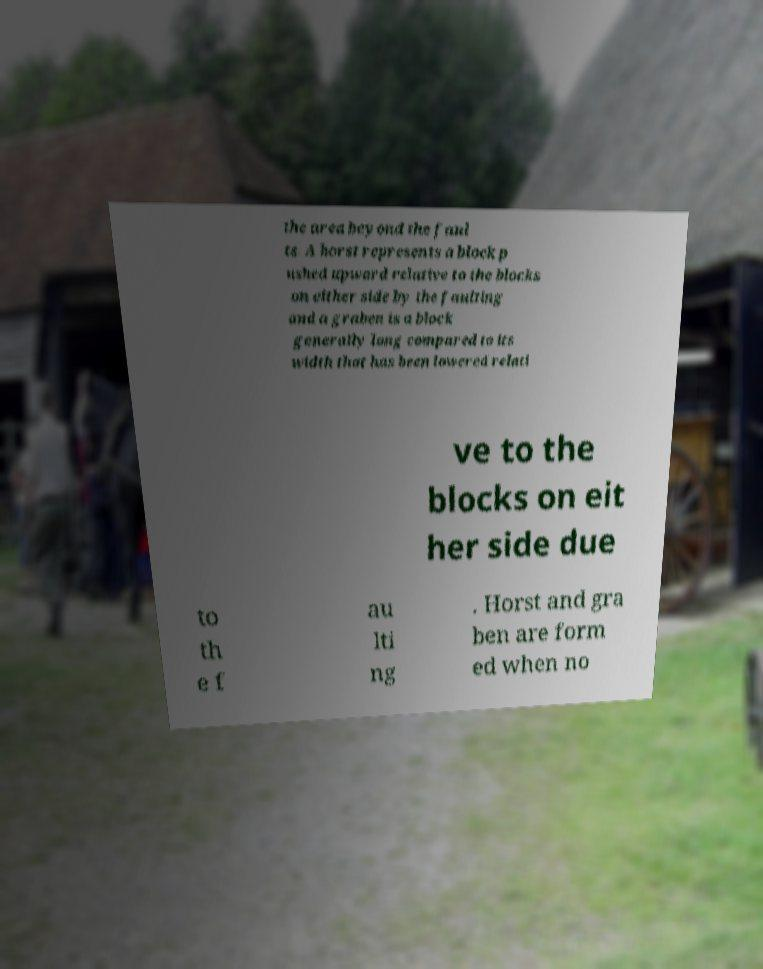Could you extract and type out the text from this image? the area beyond the faul ts. A horst represents a block p ushed upward relative to the blocks on either side by the faulting and a graben is a block generally long compared to its width that has been lowered relati ve to the blocks on eit her side due to th e f au lti ng . Horst and gra ben are form ed when no 